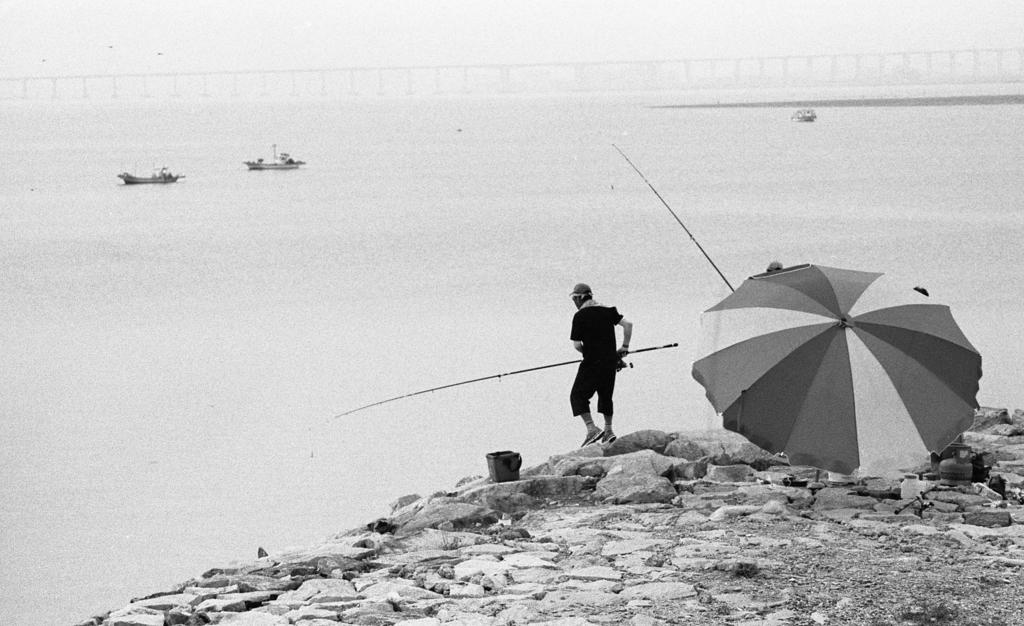What object is located on the right side of the image? There is an umbrella on the right side of the image. What is the man in the image holding? The man is holding a stick in the image. What can be seen in the background of the image? There is water visible in the image, and boats are on the water. What type of dust can be seen covering the boats in the image? There is no dust visible in the image; the boats are on the water, and the water appears to be clear. 